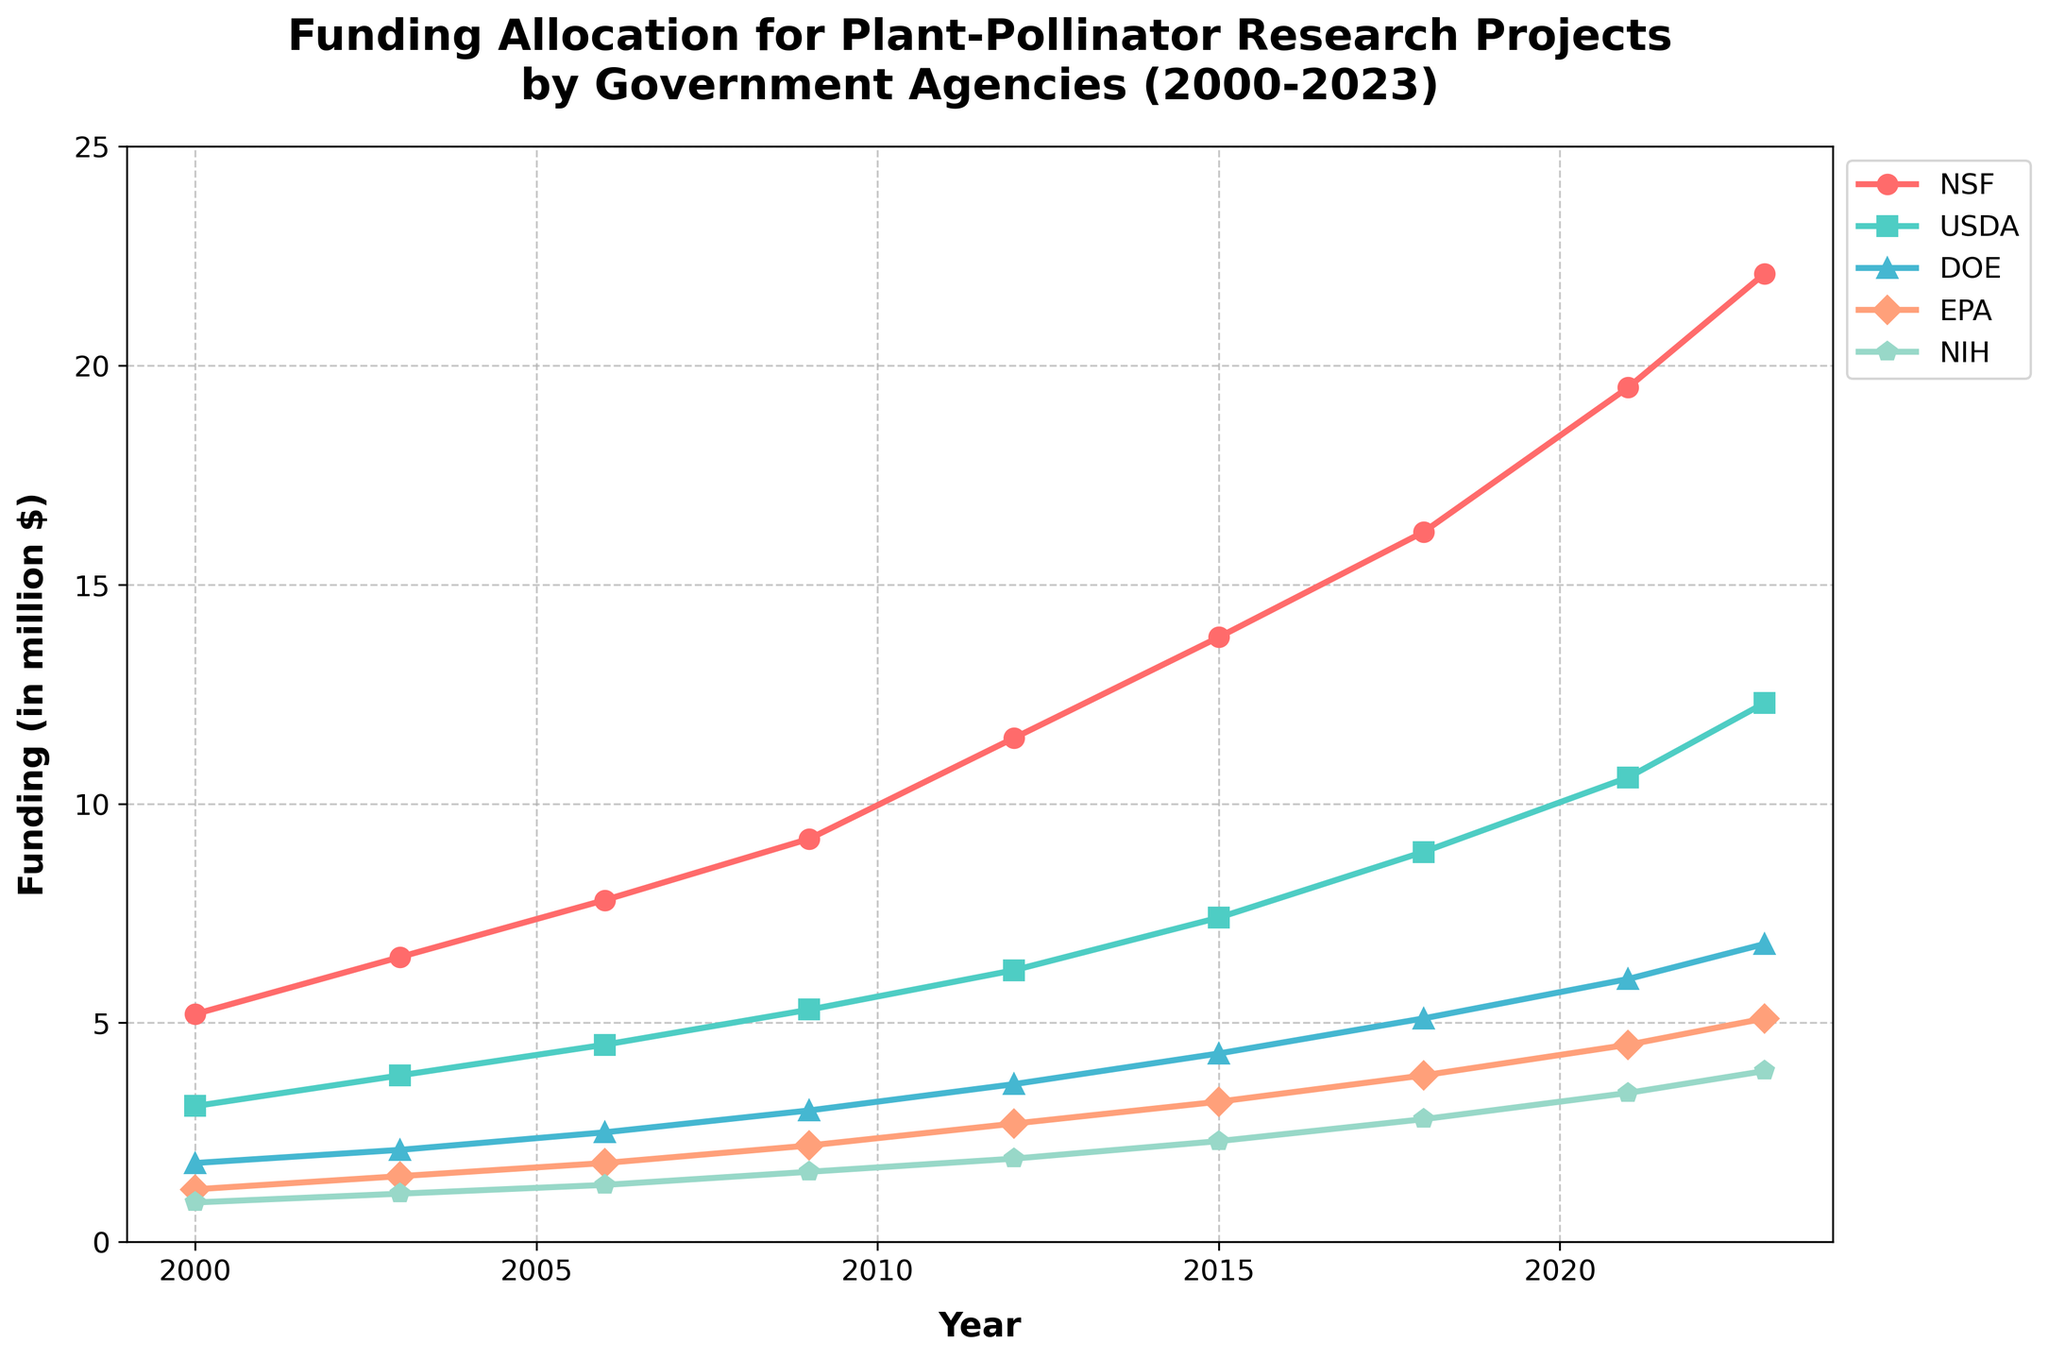What's the trend of NIH funding from 2000 to 2023? From the figure, observe the line representing NIH funding over the years. The NIH funding starts at 0.9 million in 2000 and steadily increases to 3.9 million in 2023, showing a consistent upward trend over the given period.
Answer: Upward trend Which agency showed the highest growth in funding from 2000 to 2023? Compare the starting and ending points for each agency’s funding. NSF starts at 5.2 million in 2000 and ends at 22.1 million in 2023, showing an increase of 16.9 million, which is higher than the increases of other agencies.
Answer: NSF How much more funding did NSF receive compared to USDA in 2015? Look at the 2015 funding data for NSF and USDA. NSF received 13.8 million, and USDA received 7.4 million. Calculate the difference: 13.8 - 7.4 = 6.4 million.
Answer: 6.4 million Which agency had the least consistent growth over the years, according to the visual representation? Examine the smoothness and regularity of the lines for all agencies. The EPA line shows less consistent increases with noticeable fluctuations compared to other agencies.
Answer: EPA What is the average funding for DOE from 2000 to 2023? Sum the DOE funding values over the years and divide by the number of years (assuming data points count: 9). (1.8 + 2.1 + 2.5 + 3.0 + 3.6 + 4.3 + 5.1 + 6.0 + 6.8) / 9 = 3.6.
Answer: 3.6 million By how much did EPA funding increase from 2000 to 2023? Check EPA funding values for 2000 and 2023. EPA funding in 2000 was 1.2 million and in 2023 was 5.1 million. The increase is 5.1 - 1.2 = 3.9 million.
Answer: 3.9 million In which year did NIH funding first exceed 2 million? Follow the NIH line and check when it first crossed the 2 million mark. In 2009, NIH funding was 1.6 million, and in 2012 it was 1.9 million, and in 2015 it was 2.3 million. So, the first year it exceeded 2 million is 2015.
Answer: 2015 Which agency had the highest funding in 2021? Compare the funding amounts for all agencies in 2021. NSF had the highest funding at 19.5 million.
Answer: NSF 